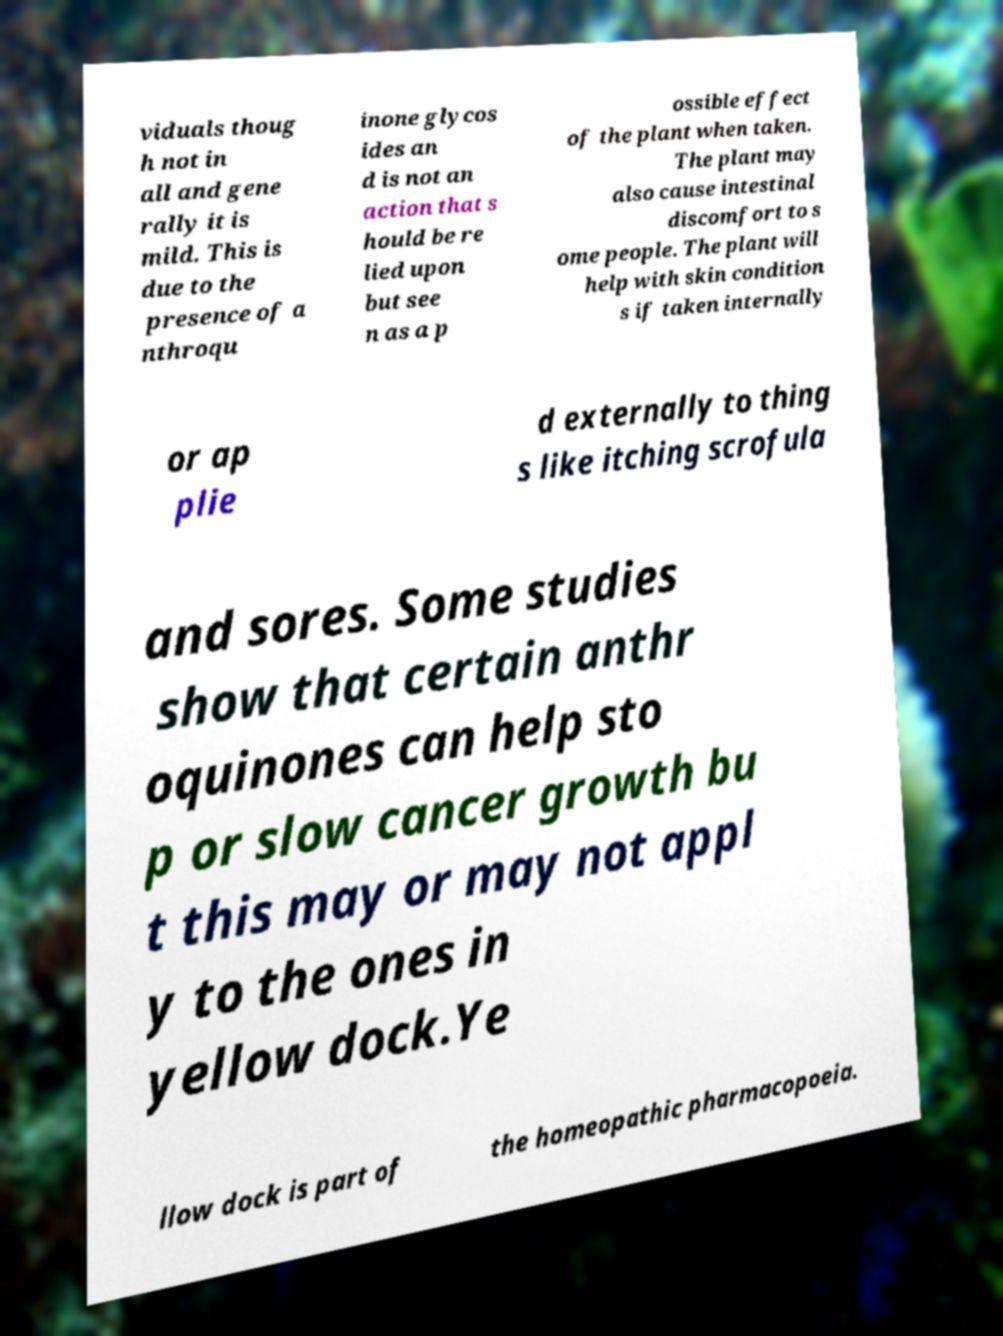Please read and relay the text visible in this image. What does it say? viduals thoug h not in all and gene rally it is mild. This is due to the presence of a nthroqu inone glycos ides an d is not an action that s hould be re lied upon but see n as a p ossible effect of the plant when taken. The plant may also cause intestinal discomfort to s ome people. The plant will help with skin condition s if taken internally or ap plie d externally to thing s like itching scrofula and sores. Some studies show that certain anthr oquinones can help sto p or slow cancer growth bu t this may or may not appl y to the ones in yellow dock.Ye llow dock is part of the homeopathic pharmacopoeia. 